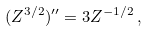Convert formula to latex. <formula><loc_0><loc_0><loc_500><loc_500>( Z ^ { 3 / 2 } ) ^ { \prime \prime } = 3 Z ^ { - 1 / 2 } \, ,</formula> 